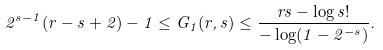Convert formula to latex. <formula><loc_0><loc_0><loc_500><loc_500>2 ^ { s - 1 } ( r - s + 2 ) - 1 \leq G _ { 1 } ( r , s ) \leq \frac { r s - \log s ! } { - \log ( 1 - 2 ^ { - s } ) } .</formula> 